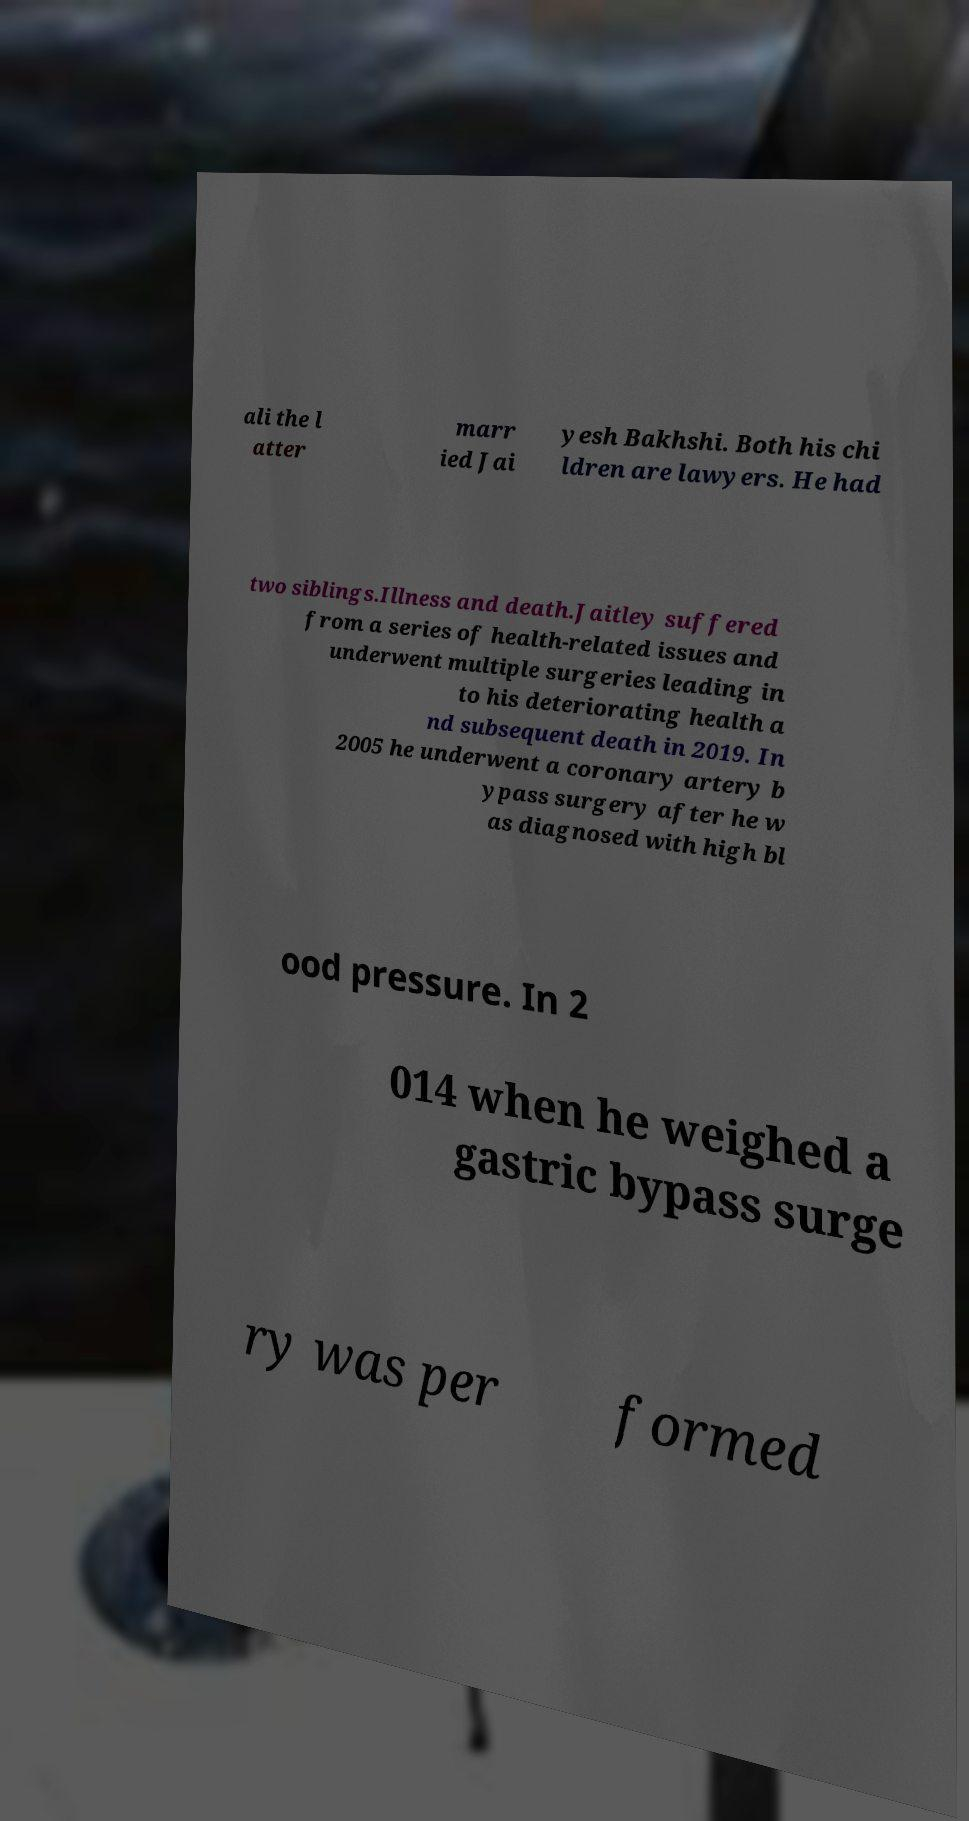Please identify and transcribe the text found in this image. ali the l atter marr ied Jai yesh Bakhshi. Both his chi ldren are lawyers. He had two siblings.Illness and death.Jaitley suffered from a series of health-related issues and underwent multiple surgeries leading in to his deteriorating health a nd subsequent death in 2019. In 2005 he underwent a coronary artery b ypass surgery after he w as diagnosed with high bl ood pressure. In 2 014 when he weighed a gastric bypass surge ry was per formed 